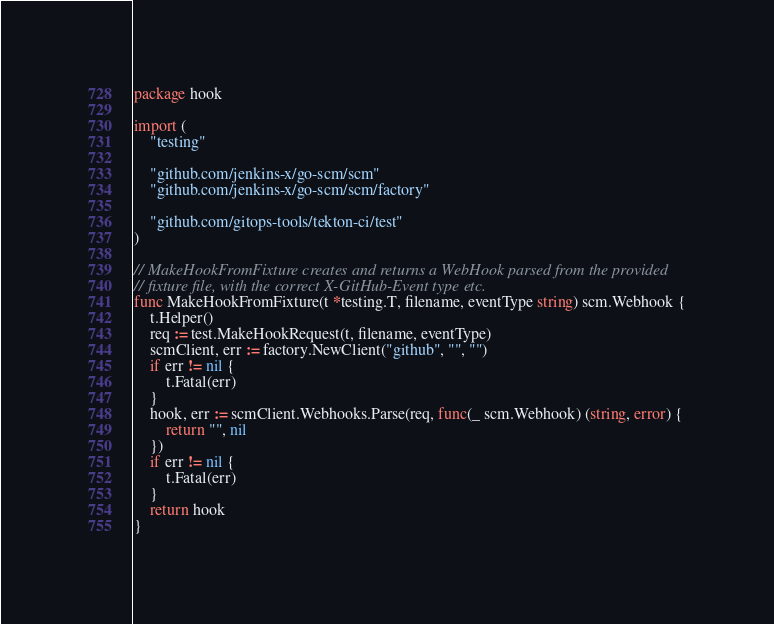<code> <loc_0><loc_0><loc_500><loc_500><_Go_>package hook

import (
	"testing"

	"github.com/jenkins-x/go-scm/scm"
	"github.com/jenkins-x/go-scm/scm/factory"

	"github.com/gitops-tools/tekton-ci/test"
)

// MakeHookFromFixture creates and returns a WebHook parsed from the provided
// fixture file, with the correct X-GitHub-Event type etc.
func MakeHookFromFixture(t *testing.T, filename, eventType string) scm.Webhook {
	t.Helper()
	req := test.MakeHookRequest(t, filename, eventType)
	scmClient, err := factory.NewClient("github", "", "")
	if err != nil {
		t.Fatal(err)
	}
	hook, err := scmClient.Webhooks.Parse(req, func(_ scm.Webhook) (string, error) {
		return "", nil
	})
	if err != nil {
		t.Fatal(err)
	}
	return hook
}
</code> 